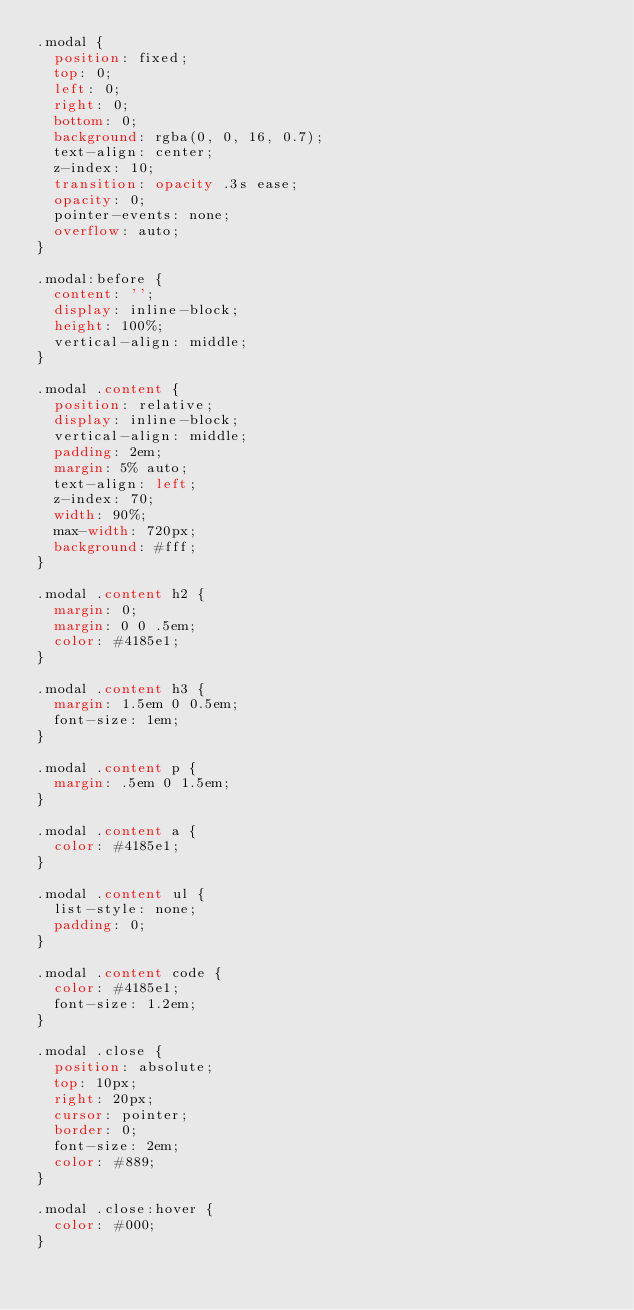<code> <loc_0><loc_0><loc_500><loc_500><_CSS_>.modal {
  position: fixed;
  top: 0;
  left: 0;
  right: 0;
  bottom: 0;
  background: rgba(0, 0, 16, 0.7);
  text-align: center;
  z-index: 10;
  transition: opacity .3s ease;
  opacity: 0;
  pointer-events: none;
  overflow: auto;
}

.modal:before {
  content: '';
  display: inline-block;
  height: 100%;
  vertical-align: middle;
}

.modal .content {
  position: relative;
  display: inline-block;
  vertical-align: middle;
  padding: 2em;
  margin: 5% auto;
  text-align: left;
  z-index: 70;
  width: 90%;
  max-width: 720px;
  background: #fff;
}

.modal .content h2 {
  margin: 0;
  margin: 0 0 .5em;
  color: #4185e1;
}

.modal .content h3 {
  margin: 1.5em 0 0.5em;
  font-size: 1em;
}

.modal .content p {
  margin: .5em 0 1.5em;
}

.modal .content a {
  color: #4185e1;
}

.modal .content ul {
  list-style: none;
  padding: 0;
}

.modal .content code {
  color: #4185e1;
  font-size: 1.2em;
}

.modal .close {
  position: absolute;
  top: 10px;
  right: 20px;
  cursor: pointer;
  border: 0;
  font-size: 2em;
  color: #889;
}

.modal .close:hover {
  color: #000;
}
</code> 